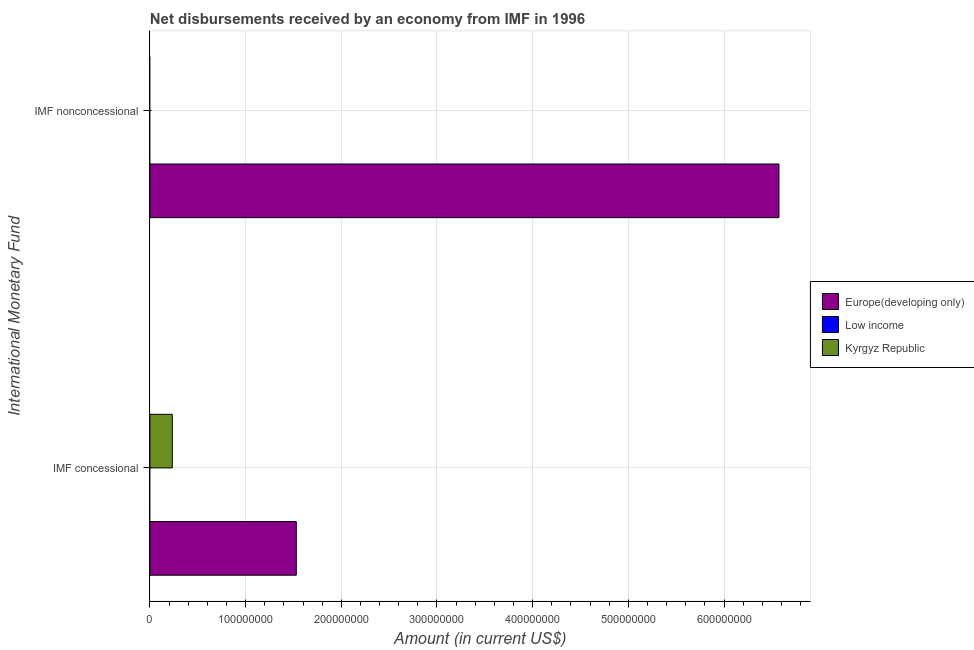How many different coloured bars are there?
Your answer should be very brief. 2. Are the number of bars on each tick of the Y-axis equal?
Your answer should be compact. No. What is the label of the 1st group of bars from the top?
Keep it short and to the point. IMF nonconcessional. What is the net concessional disbursements from imf in Kyrgyz Republic?
Give a very brief answer. 2.34e+07. Across all countries, what is the maximum net non concessional disbursements from imf?
Your answer should be compact. 6.57e+08. Across all countries, what is the minimum net non concessional disbursements from imf?
Ensure brevity in your answer.  0. In which country was the net non concessional disbursements from imf maximum?
Keep it short and to the point. Europe(developing only). What is the total net non concessional disbursements from imf in the graph?
Give a very brief answer. 6.57e+08. What is the difference between the net non concessional disbursements from imf in Low income and the net concessional disbursements from imf in Kyrgyz Republic?
Make the answer very short. -2.34e+07. What is the average net non concessional disbursements from imf per country?
Provide a short and direct response. 2.19e+08. What is the difference between the net concessional disbursements from imf and net non concessional disbursements from imf in Europe(developing only)?
Provide a short and direct response. -5.04e+08. In how many countries, is the net non concessional disbursements from imf greater than 460000000 US$?
Make the answer very short. 1. What is the ratio of the net concessional disbursements from imf in Europe(developing only) to that in Kyrgyz Republic?
Ensure brevity in your answer.  6.53. Is the net concessional disbursements from imf in Kyrgyz Republic less than that in Europe(developing only)?
Give a very brief answer. Yes. In how many countries, is the net concessional disbursements from imf greater than the average net concessional disbursements from imf taken over all countries?
Keep it short and to the point. 1. How many countries are there in the graph?
Keep it short and to the point. 3. Are the values on the major ticks of X-axis written in scientific E-notation?
Ensure brevity in your answer.  No. Where does the legend appear in the graph?
Your response must be concise. Center right. How many legend labels are there?
Provide a short and direct response. 3. How are the legend labels stacked?
Offer a very short reply. Vertical. What is the title of the graph?
Ensure brevity in your answer.  Net disbursements received by an economy from IMF in 1996. What is the label or title of the Y-axis?
Your answer should be compact. International Monetary Fund. What is the Amount (in current US$) in Europe(developing only) in IMF concessional?
Your answer should be compact. 1.53e+08. What is the Amount (in current US$) in Kyrgyz Republic in IMF concessional?
Offer a very short reply. 2.34e+07. What is the Amount (in current US$) of Europe(developing only) in IMF nonconcessional?
Offer a very short reply. 6.57e+08. What is the Amount (in current US$) of Low income in IMF nonconcessional?
Offer a terse response. 0. Across all International Monetary Fund, what is the maximum Amount (in current US$) of Europe(developing only)?
Ensure brevity in your answer.  6.57e+08. Across all International Monetary Fund, what is the maximum Amount (in current US$) of Kyrgyz Republic?
Ensure brevity in your answer.  2.34e+07. Across all International Monetary Fund, what is the minimum Amount (in current US$) of Europe(developing only)?
Your response must be concise. 1.53e+08. What is the total Amount (in current US$) in Europe(developing only) in the graph?
Your response must be concise. 8.10e+08. What is the total Amount (in current US$) of Low income in the graph?
Give a very brief answer. 0. What is the total Amount (in current US$) of Kyrgyz Republic in the graph?
Ensure brevity in your answer.  2.34e+07. What is the difference between the Amount (in current US$) of Europe(developing only) in IMF concessional and that in IMF nonconcessional?
Ensure brevity in your answer.  -5.04e+08. What is the average Amount (in current US$) of Europe(developing only) per International Monetary Fund?
Provide a succinct answer. 4.05e+08. What is the average Amount (in current US$) of Low income per International Monetary Fund?
Ensure brevity in your answer.  0. What is the average Amount (in current US$) in Kyrgyz Republic per International Monetary Fund?
Ensure brevity in your answer.  1.17e+07. What is the difference between the Amount (in current US$) of Europe(developing only) and Amount (in current US$) of Kyrgyz Republic in IMF concessional?
Give a very brief answer. 1.30e+08. What is the ratio of the Amount (in current US$) in Europe(developing only) in IMF concessional to that in IMF nonconcessional?
Make the answer very short. 0.23. What is the difference between the highest and the second highest Amount (in current US$) of Europe(developing only)?
Make the answer very short. 5.04e+08. What is the difference between the highest and the lowest Amount (in current US$) of Europe(developing only)?
Keep it short and to the point. 5.04e+08. What is the difference between the highest and the lowest Amount (in current US$) in Kyrgyz Republic?
Offer a terse response. 2.34e+07. 